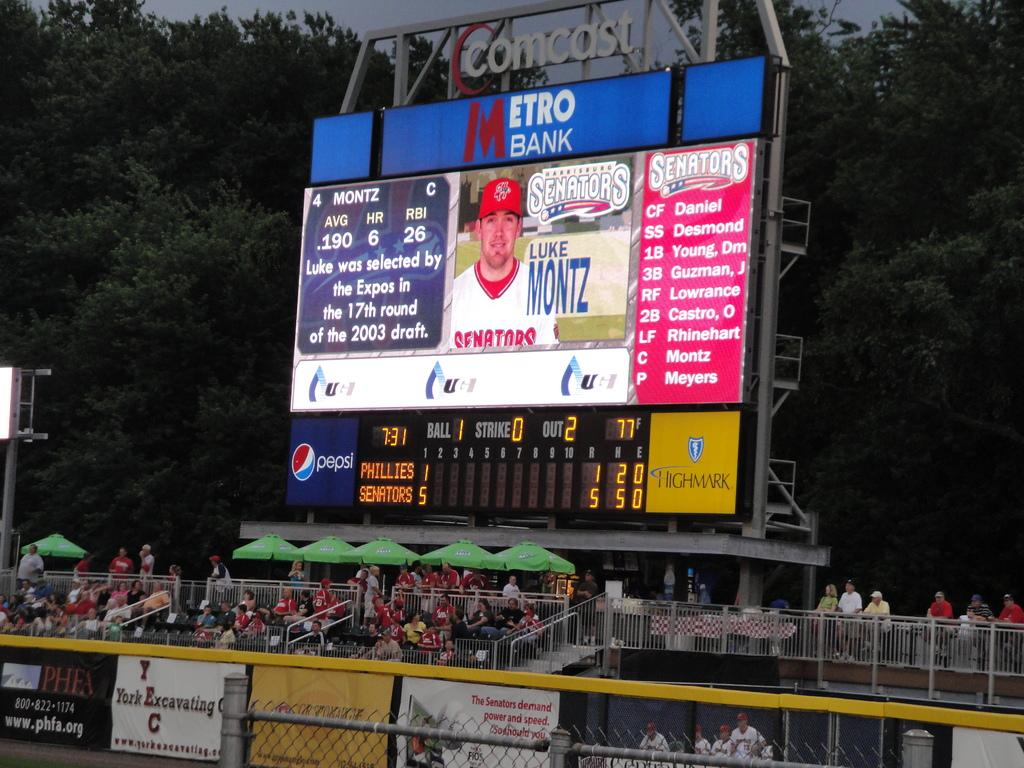<image>
Create a compact narrative representing the image presented. A group of people in the bleachers at the Comcast stadium. 